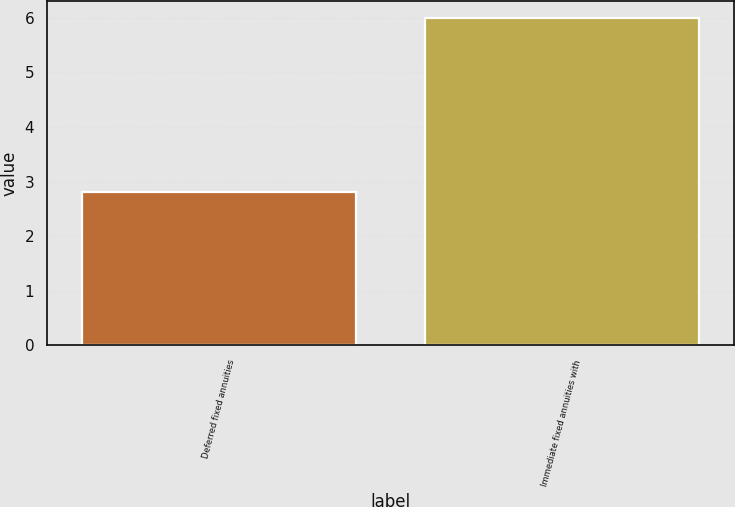Convert chart. <chart><loc_0><loc_0><loc_500><loc_500><bar_chart><fcel>Deferred fixed annuities<fcel>Immediate fixed annuities with<nl><fcel>2.8<fcel>6<nl></chart> 